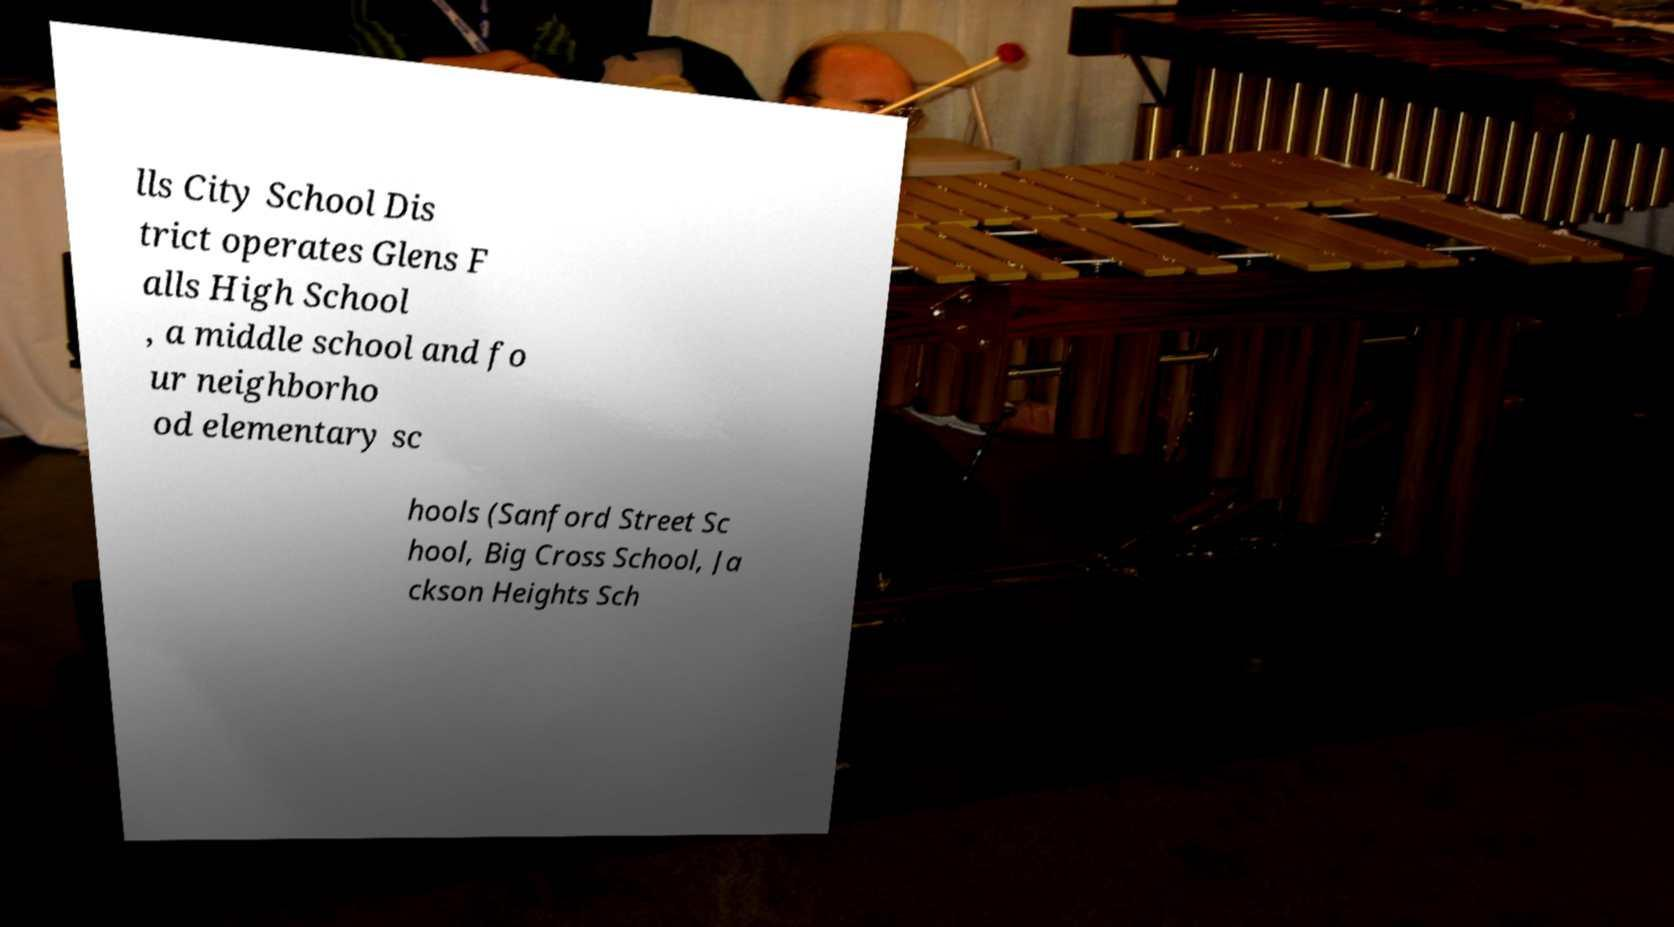Can you accurately transcribe the text from the provided image for me? lls City School Dis trict operates Glens F alls High School , a middle school and fo ur neighborho od elementary sc hools (Sanford Street Sc hool, Big Cross School, Ja ckson Heights Sch 